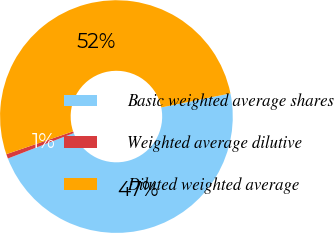Convert chart to OTSL. <chart><loc_0><loc_0><loc_500><loc_500><pie_chart><fcel>Basic weighted average shares<fcel>Weighted average dilutive<fcel>Diluted weighted average<nl><fcel>47.32%<fcel>0.63%<fcel>52.05%<nl></chart> 